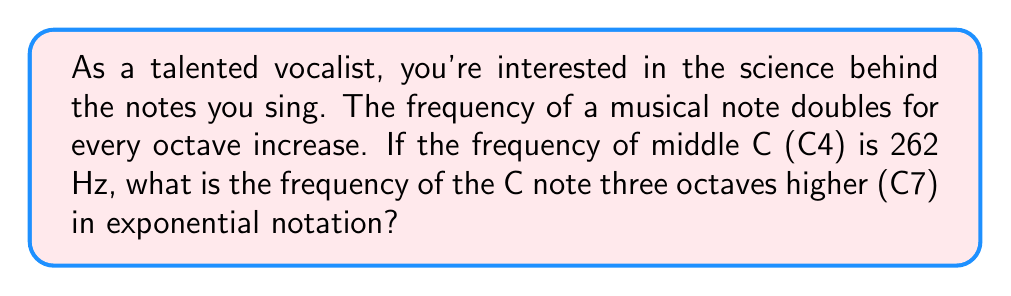Can you solve this math problem? To solve this problem, let's break it down step-by-step:

1) We know that the frequency doubles for each octave increase. This means we can represent this relationship using exponents.

2) Let's define our base frequency:
   $f_0 = 262$ Hz (the frequency of C4)

3) For each octave increase, we multiply by 2:
   - One octave higher (C5): $f_1 = 262 \cdot 2^1$
   - Two octaves higher (C6): $f_2 = 262 \cdot 2^2$
   - Three octaves higher (C7): $f_3 = 262 \cdot 2^3$

4) We're asked about C7, which is three octaves higher than C4. So we use:

   $$f_3 = 262 \cdot 2^3$$

5) This is already in exponential notation, but we can simplify it further:

   $$f_3 = 262 \cdot 8 = 2096$$

6) To express this in scientific notation (which is a form of exponential notation):

   $$f_3 = 2.096 \cdot 10^3 \text{ Hz}$$

This final form is the most compact way to express the frequency in exponential notation.
Answer: $2.096 \cdot 10^3 \text{ Hz}$ 